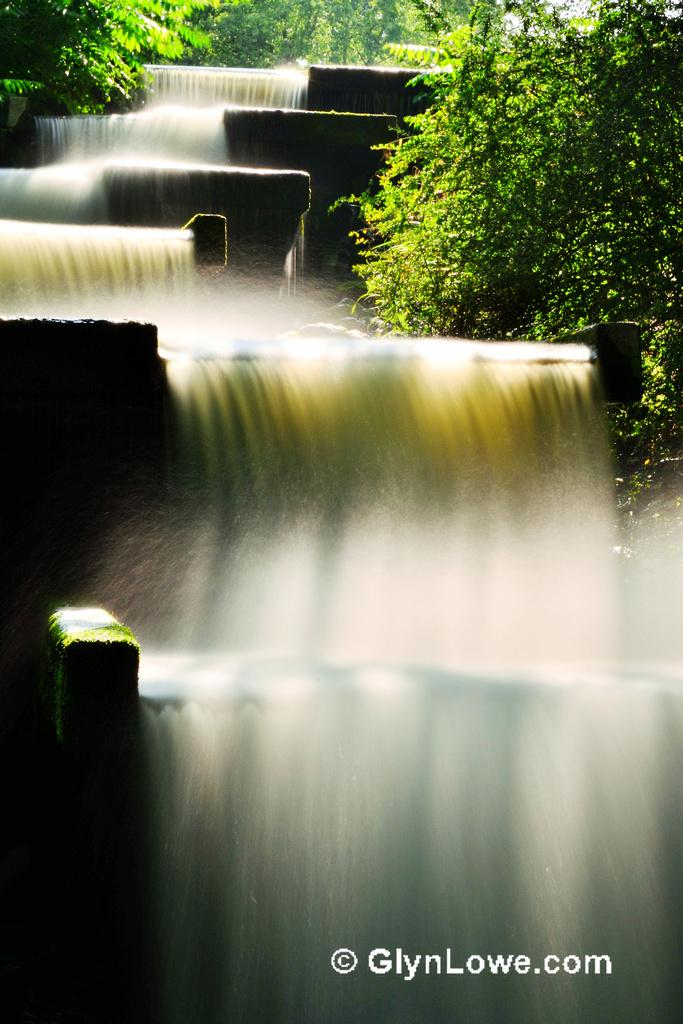What is happening in the image? There is water flowing in the image. What can be seen on either side of the water? Plants and trees are present on either side of the water. What type of government is depicted in the image? There is no government depicted in the image; it features water flowing with plants and trees on either side. How many goldfish can be seen swimming in the water in the image? There are no goldfish present in the image; it features water flowing with plants and trees on either side. 